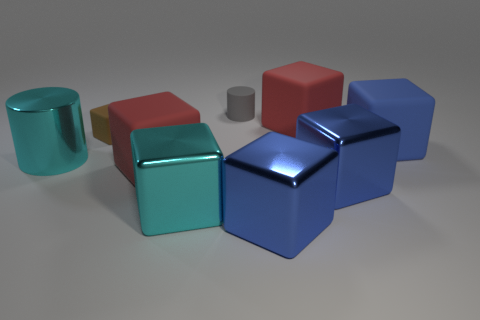Subtract all blue cubes. How many were subtracted if there are1blue cubes left? 2 Subtract all big red matte blocks. How many blocks are left? 5 Subtract 1 blocks. How many blocks are left? 6 Subtract all cyan cylinders. How many cylinders are left? 1 Subtract all cylinders. How many objects are left? 7 Subtract all gray cubes. Subtract all red cylinders. How many cubes are left? 7 Subtract all yellow spheres. How many green cubes are left? 0 Subtract all gray rubber spheres. Subtract all large cyan cylinders. How many objects are left? 8 Add 5 blue blocks. How many blue blocks are left? 8 Add 2 small blue metallic balls. How many small blue metallic balls exist? 2 